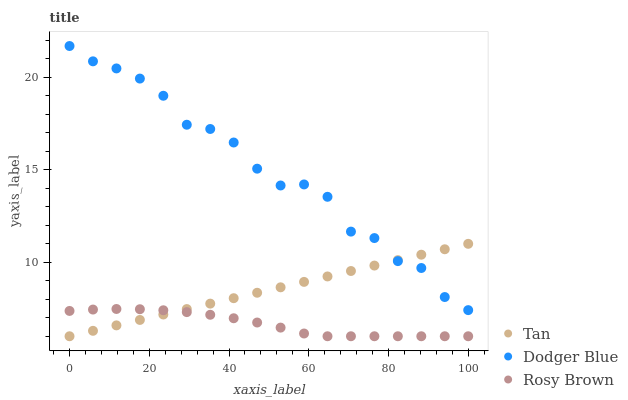Does Rosy Brown have the minimum area under the curve?
Answer yes or no. Yes. Does Dodger Blue have the maximum area under the curve?
Answer yes or no. Yes. Does Dodger Blue have the minimum area under the curve?
Answer yes or no. No. Does Rosy Brown have the maximum area under the curve?
Answer yes or no. No. Is Tan the smoothest?
Answer yes or no. Yes. Is Dodger Blue the roughest?
Answer yes or no. Yes. Is Rosy Brown the smoothest?
Answer yes or no. No. Is Rosy Brown the roughest?
Answer yes or no. No. Does Tan have the lowest value?
Answer yes or no. Yes. Does Dodger Blue have the lowest value?
Answer yes or no. No. Does Dodger Blue have the highest value?
Answer yes or no. Yes. Does Rosy Brown have the highest value?
Answer yes or no. No. Is Rosy Brown less than Dodger Blue?
Answer yes or no. Yes. Is Dodger Blue greater than Rosy Brown?
Answer yes or no. Yes. Does Dodger Blue intersect Tan?
Answer yes or no. Yes. Is Dodger Blue less than Tan?
Answer yes or no. No. Is Dodger Blue greater than Tan?
Answer yes or no. No. Does Rosy Brown intersect Dodger Blue?
Answer yes or no. No. 